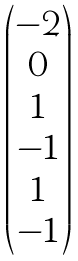<formula> <loc_0><loc_0><loc_500><loc_500>\begin{pmatrix} - 2 \\ 0 \\ 1 \\ - 1 \\ 1 \\ - 1 \end{pmatrix}</formula> 